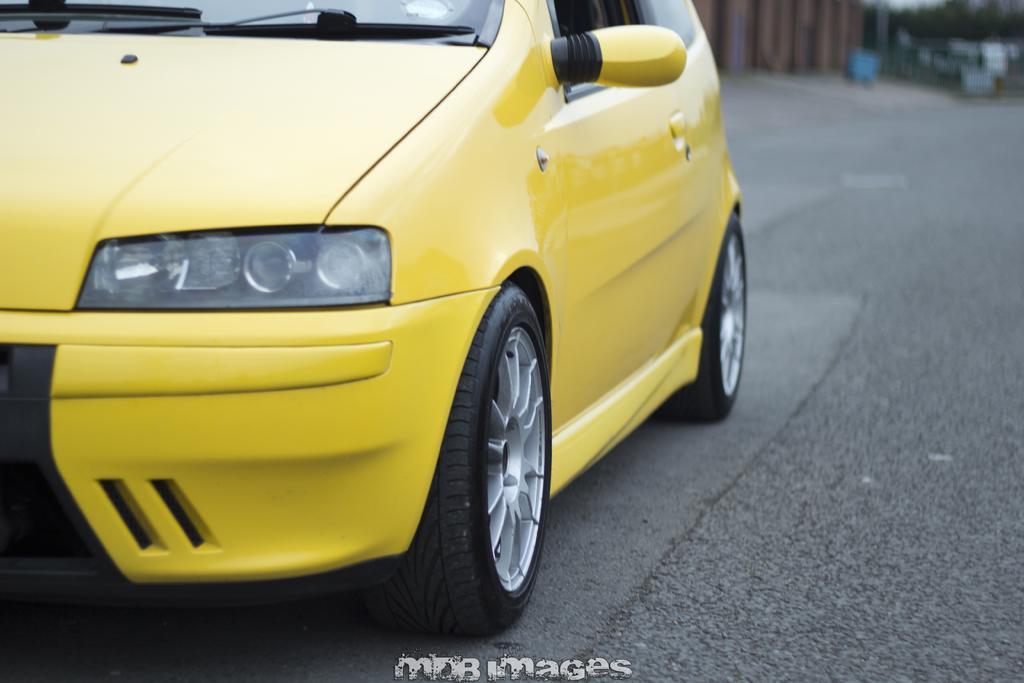Could you give a brief overview of what you see in this image? In this image we can see a yellow color car on the road. At the bottom of the image there is some text. 